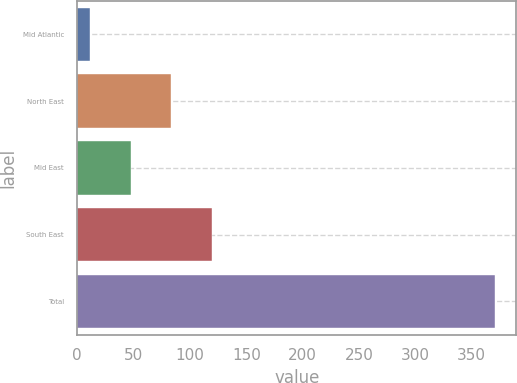Convert chart to OTSL. <chart><loc_0><loc_0><loc_500><loc_500><bar_chart><fcel>Mid Atlantic<fcel>North East<fcel>Mid East<fcel>South East<fcel>Total<nl><fcel>11.3<fcel>83.24<fcel>47.27<fcel>119.21<fcel>371<nl></chart> 